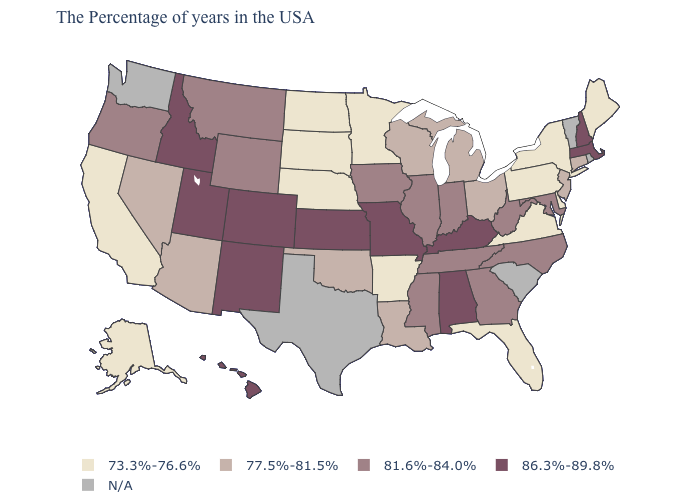Does the first symbol in the legend represent the smallest category?
Concise answer only. Yes. Does the first symbol in the legend represent the smallest category?
Answer briefly. Yes. What is the value of North Dakota?
Give a very brief answer. 73.3%-76.6%. What is the value of Georgia?
Answer briefly. 81.6%-84.0%. What is the value of Indiana?
Quick response, please. 81.6%-84.0%. What is the highest value in states that border Idaho?
Keep it brief. 86.3%-89.8%. Among the states that border Pennsylvania , does Delaware have the lowest value?
Short answer required. Yes. What is the highest value in states that border Kansas?
Give a very brief answer. 86.3%-89.8%. Does Massachusetts have the lowest value in the USA?
Write a very short answer. No. Does Oregon have the highest value in the West?
Short answer required. No. Among the states that border Alabama , which have the lowest value?
Keep it brief. Florida. Is the legend a continuous bar?
Write a very short answer. No. What is the value of Alabama?
Be succinct. 86.3%-89.8%. 